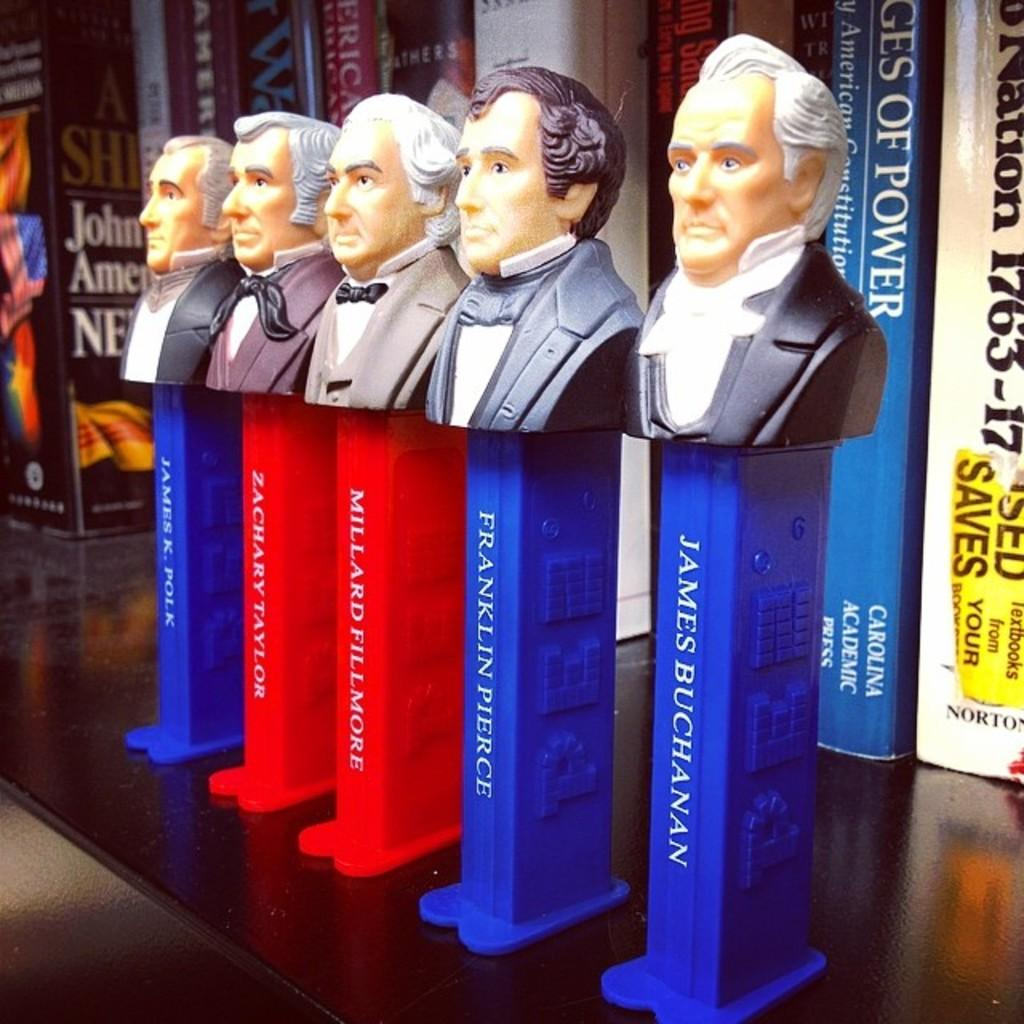<image>
Summarize the visual content of the image. Pez dispensers of presidents including james buchanan and franklin pierce 